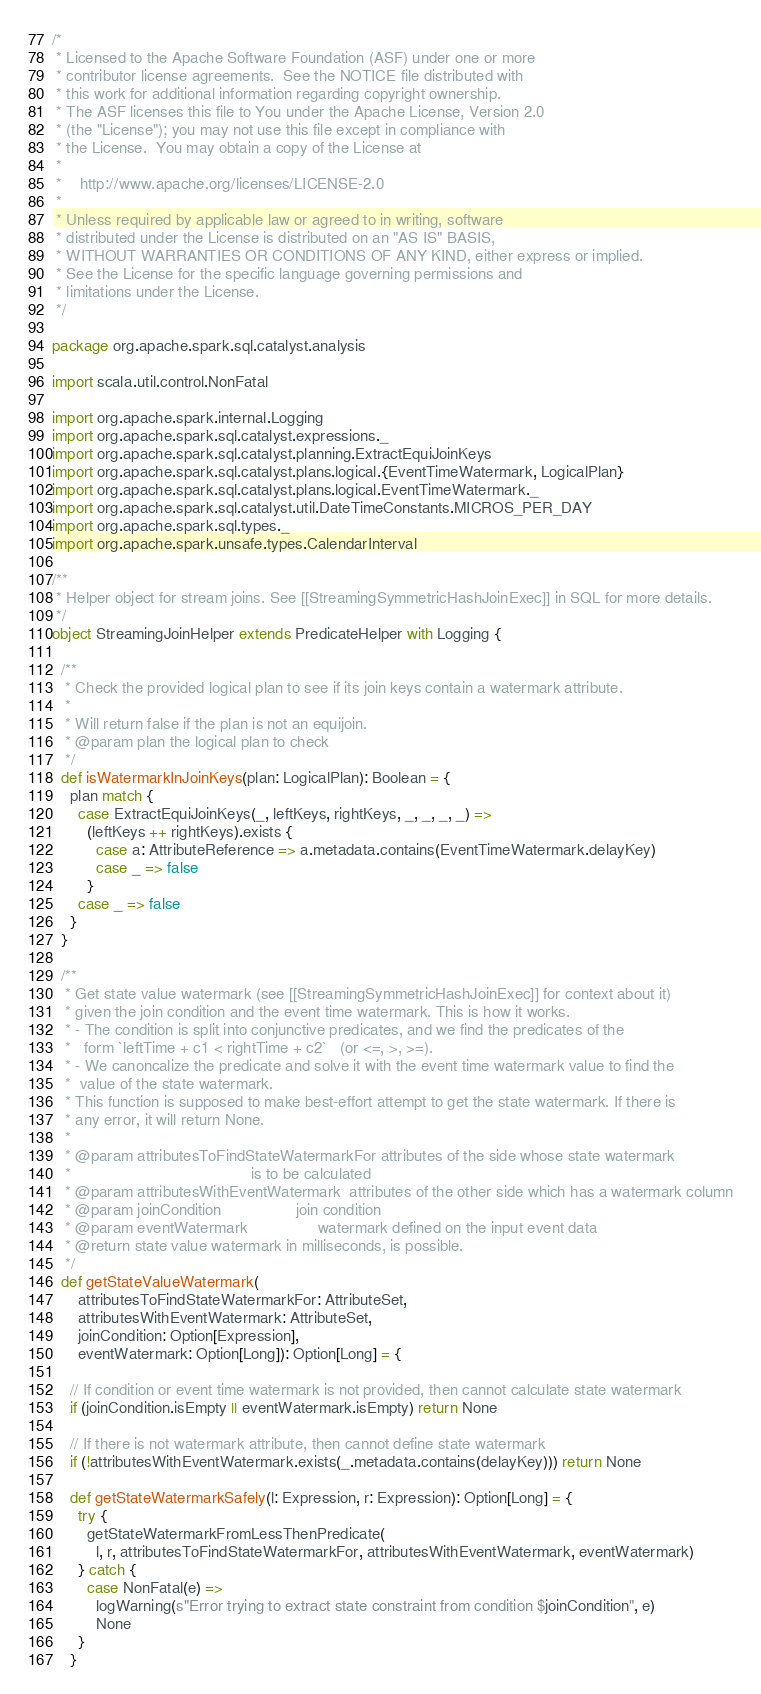Convert code to text. <code><loc_0><loc_0><loc_500><loc_500><_Scala_>/*
 * Licensed to the Apache Software Foundation (ASF) under one or more
 * contributor license agreements.  See the NOTICE file distributed with
 * this work for additional information regarding copyright ownership.
 * The ASF licenses this file to You under the Apache License, Version 2.0
 * (the "License"); you may not use this file except in compliance with
 * the License.  You may obtain a copy of the License at
 *
 *    http://www.apache.org/licenses/LICENSE-2.0
 *
 * Unless required by applicable law or agreed to in writing, software
 * distributed under the License is distributed on an "AS IS" BASIS,
 * WITHOUT WARRANTIES OR CONDITIONS OF ANY KIND, either express or implied.
 * See the License for the specific language governing permissions and
 * limitations under the License.
 */

package org.apache.spark.sql.catalyst.analysis

import scala.util.control.NonFatal

import org.apache.spark.internal.Logging
import org.apache.spark.sql.catalyst.expressions._
import org.apache.spark.sql.catalyst.planning.ExtractEquiJoinKeys
import org.apache.spark.sql.catalyst.plans.logical.{EventTimeWatermark, LogicalPlan}
import org.apache.spark.sql.catalyst.plans.logical.EventTimeWatermark._
import org.apache.spark.sql.catalyst.util.DateTimeConstants.MICROS_PER_DAY
import org.apache.spark.sql.types._
import org.apache.spark.unsafe.types.CalendarInterval

/**
 * Helper object for stream joins. See [[StreamingSymmetricHashJoinExec]] in SQL for more details.
 */
object StreamingJoinHelper extends PredicateHelper with Logging {

  /**
   * Check the provided logical plan to see if its join keys contain a watermark attribute.
   *
   * Will return false if the plan is not an equijoin.
   * @param plan the logical plan to check
   */
  def isWatermarkInJoinKeys(plan: LogicalPlan): Boolean = {
    plan match {
      case ExtractEquiJoinKeys(_, leftKeys, rightKeys, _, _, _, _) =>
        (leftKeys ++ rightKeys).exists {
          case a: AttributeReference => a.metadata.contains(EventTimeWatermark.delayKey)
          case _ => false
        }
      case _ => false
    }
  }

  /**
   * Get state value watermark (see [[StreamingSymmetricHashJoinExec]] for context about it)
   * given the join condition and the event time watermark. This is how it works.
   * - The condition is split into conjunctive predicates, and we find the predicates of the
   *   form `leftTime + c1 < rightTime + c2`   (or <=, >, >=).
   * - We canoncalize the predicate and solve it with the event time watermark value to find the
   *  value of the state watermark.
   * This function is supposed to make best-effort attempt to get the state watermark. If there is
   * any error, it will return None.
   *
   * @param attributesToFindStateWatermarkFor attributes of the side whose state watermark
   *                                         is to be calculated
   * @param attributesWithEventWatermark  attributes of the other side which has a watermark column
   * @param joinCondition                 join condition
   * @param eventWatermark                watermark defined on the input event data
   * @return state value watermark in milliseconds, is possible.
   */
  def getStateValueWatermark(
      attributesToFindStateWatermarkFor: AttributeSet,
      attributesWithEventWatermark: AttributeSet,
      joinCondition: Option[Expression],
      eventWatermark: Option[Long]): Option[Long] = {

    // If condition or event time watermark is not provided, then cannot calculate state watermark
    if (joinCondition.isEmpty || eventWatermark.isEmpty) return None

    // If there is not watermark attribute, then cannot define state watermark
    if (!attributesWithEventWatermark.exists(_.metadata.contains(delayKey))) return None

    def getStateWatermarkSafely(l: Expression, r: Expression): Option[Long] = {
      try {
        getStateWatermarkFromLessThenPredicate(
          l, r, attributesToFindStateWatermarkFor, attributesWithEventWatermark, eventWatermark)
      } catch {
        case NonFatal(e) =>
          logWarning(s"Error trying to extract state constraint from condition $joinCondition", e)
          None
      }
    }
</code> 